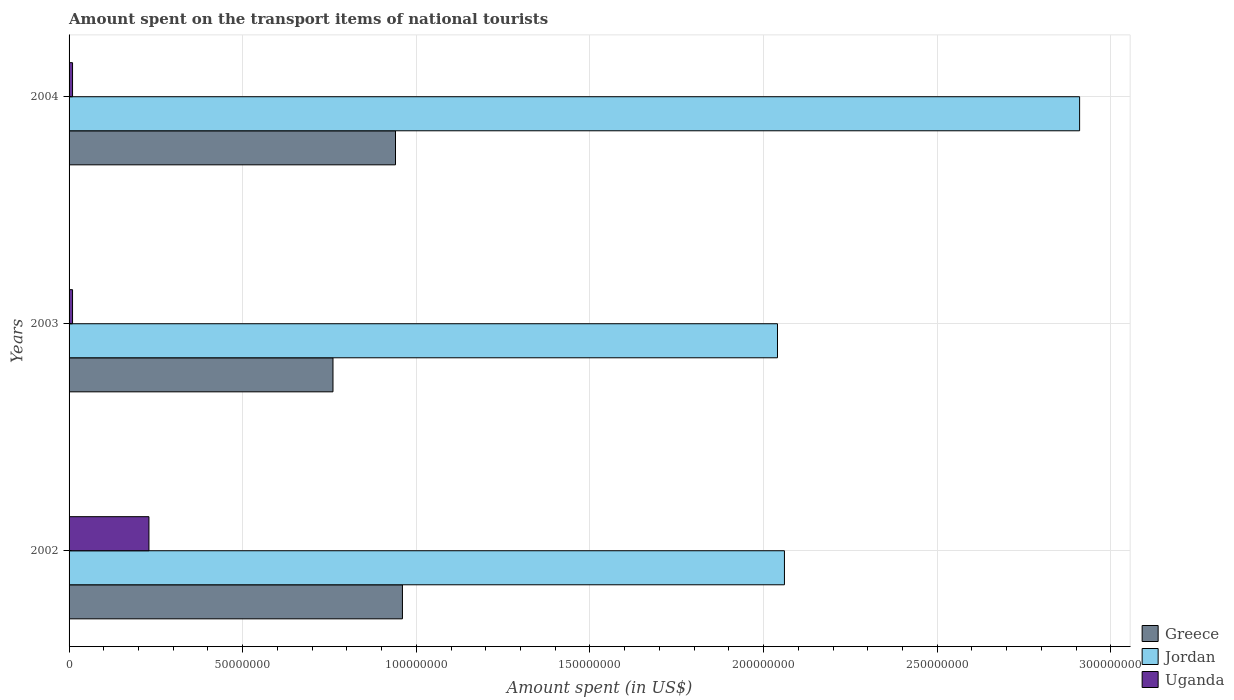Are the number of bars on each tick of the Y-axis equal?
Provide a succinct answer. Yes. What is the amount spent on the transport items of national tourists in Jordan in 2002?
Offer a terse response. 2.06e+08. Across all years, what is the maximum amount spent on the transport items of national tourists in Uganda?
Provide a succinct answer. 2.30e+07. Across all years, what is the minimum amount spent on the transport items of national tourists in Greece?
Offer a very short reply. 7.60e+07. In which year was the amount spent on the transport items of national tourists in Jordan maximum?
Offer a terse response. 2004. What is the total amount spent on the transport items of national tourists in Jordan in the graph?
Your answer should be compact. 7.01e+08. What is the difference between the amount spent on the transport items of national tourists in Greece in 2002 and that in 2004?
Your response must be concise. 2.00e+06. What is the difference between the amount spent on the transport items of national tourists in Greece in 2003 and the amount spent on the transport items of national tourists in Jordan in 2002?
Offer a terse response. -1.30e+08. What is the average amount spent on the transport items of national tourists in Uganda per year?
Offer a terse response. 8.33e+06. In the year 2003, what is the difference between the amount spent on the transport items of national tourists in Uganda and amount spent on the transport items of national tourists in Greece?
Offer a very short reply. -7.50e+07. What is the ratio of the amount spent on the transport items of national tourists in Greece in 2002 to that in 2003?
Your response must be concise. 1.26. Is the difference between the amount spent on the transport items of national tourists in Uganda in 2002 and 2004 greater than the difference between the amount spent on the transport items of national tourists in Greece in 2002 and 2004?
Keep it short and to the point. Yes. What is the difference between the highest and the lowest amount spent on the transport items of national tourists in Uganda?
Offer a very short reply. 2.20e+07. What does the 3rd bar from the top in 2004 represents?
Your response must be concise. Greece. What does the 2nd bar from the bottom in 2003 represents?
Offer a terse response. Jordan. Does the graph contain grids?
Provide a short and direct response. Yes. Where does the legend appear in the graph?
Your answer should be very brief. Bottom right. How many legend labels are there?
Give a very brief answer. 3. What is the title of the graph?
Give a very brief answer. Amount spent on the transport items of national tourists. Does "Nigeria" appear as one of the legend labels in the graph?
Provide a succinct answer. No. What is the label or title of the X-axis?
Make the answer very short. Amount spent (in US$). What is the label or title of the Y-axis?
Your response must be concise. Years. What is the Amount spent (in US$) in Greece in 2002?
Your response must be concise. 9.60e+07. What is the Amount spent (in US$) in Jordan in 2002?
Offer a terse response. 2.06e+08. What is the Amount spent (in US$) in Uganda in 2002?
Give a very brief answer. 2.30e+07. What is the Amount spent (in US$) in Greece in 2003?
Make the answer very short. 7.60e+07. What is the Amount spent (in US$) in Jordan in 2003?
Your answer should be very brief. 2.04e+08. What is the Amount spent (in US$) in Uganda in 2003?
Make the answer very short. 1.00e+06. What is the Amount spent (in US$) in Greece in 2004?
Offer a very short reply. 9.40e+07. What is the Amount spent (in US$) of Jordan in 2004?
Make the answer very short. 2.91e+08. What is the Amount spent (in US$) of Uganda in 2004?
Ensure brevity in your answer.  1.00e+06. Across all years, what is the maximum Amount spent (in US$) of Greece?
Your answer should be very brief. 9.60e+07. Across all years, what is the maximum Amount spent (in US$) of Jordan?
Offer a very short reply. 2.91e+08. Across all years, what is the maximum Amount spent (in US$) of Uganda?
Provide a short and direct response. 2.30e+07. Across all years, what is the minimum Amount spent (in US$) of Greece?
Give a very brief answer. 7.60e+07. Across all years, what is the minimum Amount spent (in US$) of Jordan?
Your answer should be very brief. 2.04e+08. Across all years, what is the minimum Amount spent (in US$) in Uganda?
Your response must be concise. 1.00e+06. What is the total Amount spent (in US$) of Greece in the graph?
Your answer should be very brief. 2.66e+08. What is the total Amount spent (in US$) in Jordan in the graph?
Offer a very short reply. 7.01e+08. What is the total Amount spent (in US$) of Uganda in the graph?
Your response must be concise. 2.50e+07. What is the difference between the Amount spent (in US$) in Uganda in 2002 and that in 2003?
Keep it short and to the point. 2.20e+07. What is the difference between the Amount spent (in US$) of Jordan in 2002 and that in 2004?
Your response must be concise. -8.50e+07. What is the difference between the Amount spent (in US$) of Uganda in 2002 and that in 2004?
Offer a very short reply. 2.20e+07. What is the difference between the Amount spent (in US$) of Greece in 2003 and that in 2004?
Your response must be concise. -1.80e+07. What is the difference between the Amount spent (in US$) in Jordan in 2003 and that in 2004?
Your answer should be compact. -8.70e+07. What is the difference between the Amount spent (in US$) of Greece in 2002 and the Amount spent (in US$) of Jordan in 2003?
Keep it short and to the point. -1.08e+08. What is the difference between the Amount spent (in US$) in Greece in 2002 and the Amount spent (in US$) in Uganda in 2003?
Make the answer very short. 9.50e+07. What is the difference between the Amount spent (in US$) of Jordan in 2002 and the Amount spent (in US$) of Uganda in 2003?
Your response must be concise. 2.05e+08. What is the difference between the Amount spent (in US$) in Greece in 2002 and the Amount spent (in US$) in Jordan in 2004?
Provide a short and direct response. -1.95e+08. What is the difference between the Amount spent (in US$) of Greece in 2002 and the Amount spent (in US$) of Uganda in 2004?
Your answer should be very brief. 9.50e+07. What is the difference between the Amount spent (in US$) in Jordan in 2002 and the Amount spent (in US$) in Uganda in 2004?
Offer a very short reply. 2.05e+08. What is the difference between the Amount spent (in US$) in Greece in 2003 and the Amount spent (in US$) in Jordan in 2004?
Provide a succinct answer. -2.15e+08. What is the difference between the Amount spent (in US$) in Greece in 2003 and the Amount spent (in US$) in Uganda in 2004?
Keep it short and to the point. 7.50e+07. What is the difference between the Amount spent (in US$) of Jordan in 2003 and the Amount spent (in US$) of Uganda in 2004?
Your answer should be very brief. 2.03e+08. What is the average Amount spent (in US$) of Greece per year?
Your answer should be very brief. 8.87e+07. What is the average Amount spent (in US$) of Jordan per year?
Ensure brevity in your answer.  2.34e+08. What is the average Amount spent (in US$) in Uganda per year?
Keep it short and to the point. 8.33e+06. In the year 2002, what is the difference between the Amount spent (in US$) in Greece and Amount spent (in US$) in Jordan?
Give a very brief answer. -1.10e+08. In the year 2002, what is the difference between the Amount spent (in US$) of Greece and Amount spent (in US$) of Uganda?
Your response must be concise. 7.30e+07. In the year 2002, what is the difference between the Amount spent (in US$) in Jordan and Amount spent (in US$) in Uganda?
Provide a succinct answer. 1.83e+08. In the year 2003, what is the difference between the Amount spent (in US$) in Greece and Amount spent (in US$) in Jordan?
Offer a terse response. -1.28e+08. In the year 2003, what is the difference between the Amount spent (in US$) in Greece and Amount spent (in US$) in Uganda?
Give a very brief answer. 7.50e+07. In the year 2003, what is the difference between the Amount spent (in US$) of Jordan and Amount spent (in US$) of Uganda?
Your answer should be very brief. 2.03e+08. In the year 2004, what is the difference between the Amount spent (in US$) of Greece and Amount spent (in US$) of Jordan?
Offer a terse response. -1.97e+08. In the year 2004, what is the difference between the Amount spent (in US$) of Greece and Amount spent (in US$) of Uganda?
Make the answer very short. 9.30e+07. In the year 2004, what is the difference between the Amount spent (in US$) of Jordan and Amount spent (in US$) of Uganda?
Your response must be concise. 2.90e+08. What is the ratio of the Amount spent (in US$) in Greece in 2002 to that in 2003?
Provide a succinct answer. 1.26. What is the ratio of the Amount spent (in US$) of Jordan in 2002 to that in 2003?
Your answer should be very brief. 1.01. What is the ratio of the Amount spent (in US$) in Uganda in 2002 to that in 2003?
Offer a very short reply. 23. What is the ratio of the Amount spent (in US$) in Greece in 2002 to that in 2004?
Offer a terse response. 1.02. What is the ratio of the Amount spent (in US$) of Jordan in 2002 to that in 2004?
Offer a very short reply. 0.71. What is the ratio of the Amount spent (in US$) in Uganda in 2002 to that in 2004?
Provide a short and direct response. 23. What is the ratio of the Amount spent (in US$) in Greece in 2003 to that in 2004?
Your response must be concise. 0.81. What is the ratio of the Amount spent (in US$) in Jordan in 2003 to that in 2004?
Your answer should be compact. 0.7. What is the ratio of the Amount spent (in US$) in Uganda in 2003 to that in 2004?
Your response must be concise. 1. What is the difference between the highest and the second highest Amount spent (in US$) of Jordan?
Offer a terse response. 8.50e+07. What is the difference between the highest and the second highest Amount spent (in US$) in Uganda?
Offer a very short reply. 2.20e+07. What is the difference between the highest and the lowest Amount spent (in US$) in Jordan?
Your response must be concise. 8.70e+07. What is the difference between the highest and the lowest Amount spent (in US$) in Uganda?
Your response must be concise. 2.20e+07. 